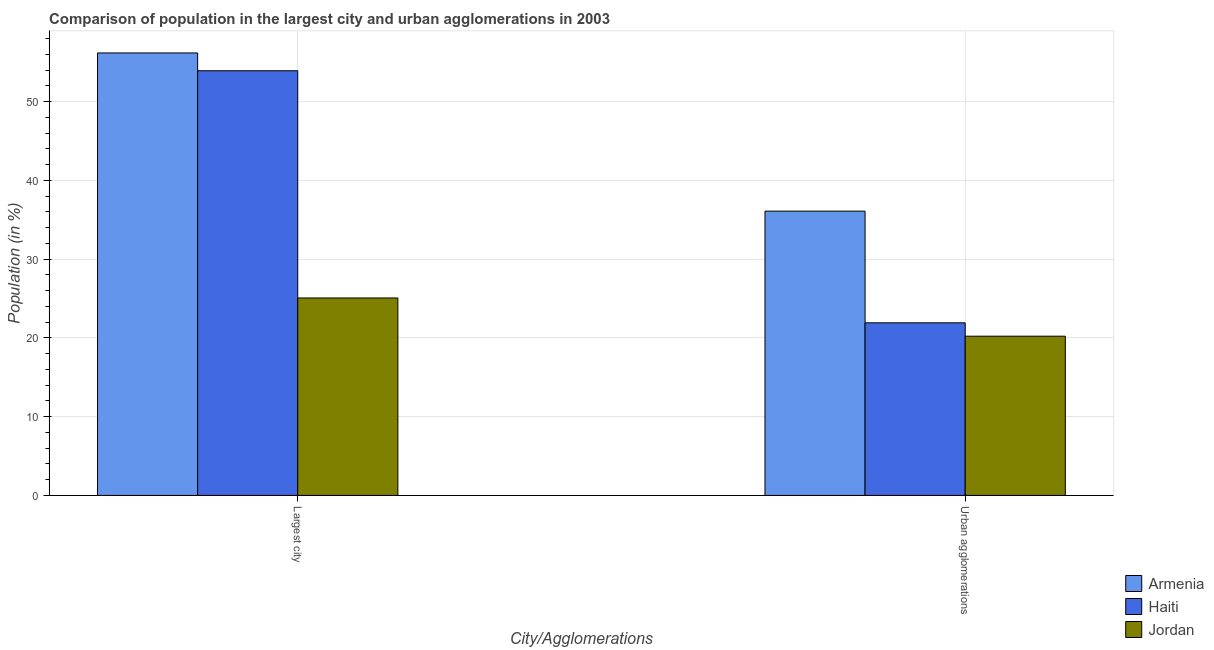Are the number of bars on each tick of the X-axis equal?
Keep it short and to the point. Yes. How many bars are there on the 1st tick from the right?
Ensure brevity in your answer.  3. What is the label of the 1st group of bars from the left?
Your response must be concise. Largest city. What is the population in urban agglomerations in Armenia?
Give a very brief answer. 36.09. Across all countries, what is the maximum population in urban agglomerations?
Make the answer very short. 36.09. Across all countries, what is the minimum population in urban agglomerations?
Provide a succinct answer. 20.21. In which country was the population in urban agglomerations maximum?
Keep it short and to the point. Armenia. In which country was the population in the largest city minimum?
Provide a succinct answer. Jordan. What is the total population in the largest city in the graph?
Your answer should be very brief. 135.16. What is the difference between the population in urban agglomerations in Armenia and that in Haiti?
Ensure brevity in your answer.  14.18. What is the difference between the population in urban agglomerations in Armenia and the population in the largest city in Haiti?
Offer a terse response. -17.82. What is the average population in urban agglomerations per country?
Make the answer very short. 26.07. What is the difference between the population in the largest city and population in urban agglomerations in Haiti?
Your response must be concise. 32. In how many countries, is the population in urban agglomerations greater than 34 %?
Your answer should be very brief. 1. What is the ratio of the population in urban agglomerations in Armenia to that in Haiti?
Keep it short and to the point. 1.65. Is the population in urban agglomerations in Jordan less than that in Haiti?
Give a very brief answer. Yes. What does the 3rd bar from the left in Urban agglomerations represents?
Your answer should be very brief. Jordan. What does the 1st bar from the right in Largest city represents?
Provide a succinct answer. Jordan. Are all the bars in the graph horizontal?
Keep it short and to the point. No. How many countries are there in the graph?
Ensure brevity in your answer.  3. Are the values on the major ticks of Y-axis written in scientific E-notation?
Offer a terse response. No. Does the graph contain any zero values?
Ensure brevity in your answer.  No. How are the legend labels stacked?
Keep it short and to the point. Vertical. What is the title of the graph?
Provide a short and direct response. Comparison of population in the largest city and urban agglomerations in 2003. What is the label or title of the X-axis?
Offer a very short reply. City/Agglomerations. What is the label or title of the Y-axis?
Give a very brief answer. Population (in %). What is the Population (in %) in Armenia in Largest city?
Offer a very short reply. 56.17. What is the Population (in %) in Haiti in Largest city?
Ensure brevity in your answer.  53.91. What is the Population (in %) of Jordan in Largest city?
Provide a succinct answer. 25.07. What is the Population (in %) in Armenia in Urban agglomerations?
Offer a very short reply. 36.09. What is the Population (in %) of Haiti in Urban agglomerations?
Offer a terse response. 21.91. What is the Population (in %) of Jordan in Urban agglomerations?
Provide a short and direct response. 20.21. Across all City/Agglomerations, what is the maximum Population (in %) in Armenia?
Your response must be concise. 56.17. Across all City/Agglomerations, what is the maximum Population (in %) in Haiti?
Make the answer very short. 53.91. Across all City/Agglomerations, what is the maximum Population (in %) in Jordan?
Your answer should be compact. 25.07. Across all City/Agglomerations, what is the minimum Population (in %) in Armenia?
Ensure brevity in your answer.  36.09. Across all City/Agglomerations, what is the minimum Population (in %) in Haiti?
Provide a succinct answer. 21.91. Across all City/Agglomerations, what is the minimum Population (in %) of Jordan?
Make the answer very short. 20.21. What is the total Population (in %) of Armenia in the graph?
Ensure brevity in your answer.  92.27. What is the total Population (in %) in Haiti in the graph?
Provide a short and direct response. 75.83. What is the total Population (in %) of Jordan in the graph?
Offer a very short reply. 45.28. What is the difference between the Population (in %) in Armenia in Largest city and that in Urban agglomerations?
Give a very brief answer. 20.08. What is the difference between the Population (in %) in Haiti in Largest city and that in Urban agglomerations?
Your answer should be very brief. 32. What is the difference between the Population (in %) in Jordan in Largest city and that in Urban agglomerations?
Your answer should be very brief. 4.85. What is the difference between the Population (in %) in Armenia in Largest city and the Population (in %) in Haiti in Urban agglomerations?
Ensure brevity in your answer.  34.26. What is the difference between the Population (in %) of Armenia in Largest city and the Population (in %) of Jordan in Urban agglomerations?
Offer a very short reply. 35.96. What is the difference between the Population (in %) in Haiti in Largest city and the Population (in %) in Jordan in Urban agglomerations?
Give a very brief answer. 33.7. What is the average Population (in %) in Armenia per City/Agglomerations?
Provide a short and direct response. 46.13. What is the average Population (in %) of Haiti per City/Agglomerations?
Offer a very short reply. 37.91. What is the average Population (in %) of Jordan per City/Agglomerations?
Your answer should be compact. 22.64. What is the difference between the Population (in %) in Armenia and Population (in %) in Haiti in Largest city?
Your answer should be very brief. 2.26. What is the difference between the Population (in %) in Armenia and Population (in %) in Jordan in Largest city?
Your answer should be compact. 31.11. What is the difference between the Population (in %) of Haiti and Population (in %) of Jordan in Largest city?
Provide a succinct answer. 28.85. What is the difference between the Population (in %) in Armenia and Population (in %) in Haiti in Urban agglomerations?
Keep it short and to the point. 14.18. What is the difference between the Population (in %) of Armenia and Population (in %) of Jordan in Urban agglomerations?
Your answer should be compact. 15.88. What is the difference between the Population (in %) of Haiti and Population (in %) of Jordan in Urban agglomerations?
Your answer should be compact. 1.7. What is the ratio of the Population (in %) in Armenia in Largest city to that in Urban agglomerations?
Your answer should be very brief. 1.56. What is the ratio of the Population (in %) in Haiti in Largest city to that in Urban agglomerations?
Offer a very short reply. 2.46. What is the ratio of the Population (in %) in Jordan in Largest city to that in Urban agglomerations?
Your answer should be compact. 1.24. What is the difference between the highest and the second highest Population (in %) of Armenia?
Your response must be concise. 20.08. What is the difference between the highest and the second highest Population (in %) in Haiti?
Keep it short and to the point. 32. What is the difference between the highest and the second highest Population (in %) in Jordan?
Your answer should be compact. 4.85. What is the difference between the highest and the lowest Population (in %) in Armenia?
Your answer should be very brief. 20.08. What is the difference between the highest and the lowest Population (in %) in Haiti?
Your response must be concise. 32. What is the difference between the highest and the lowest Population (in %) in Jordan?
Keep it short and to the point. 4.85. 